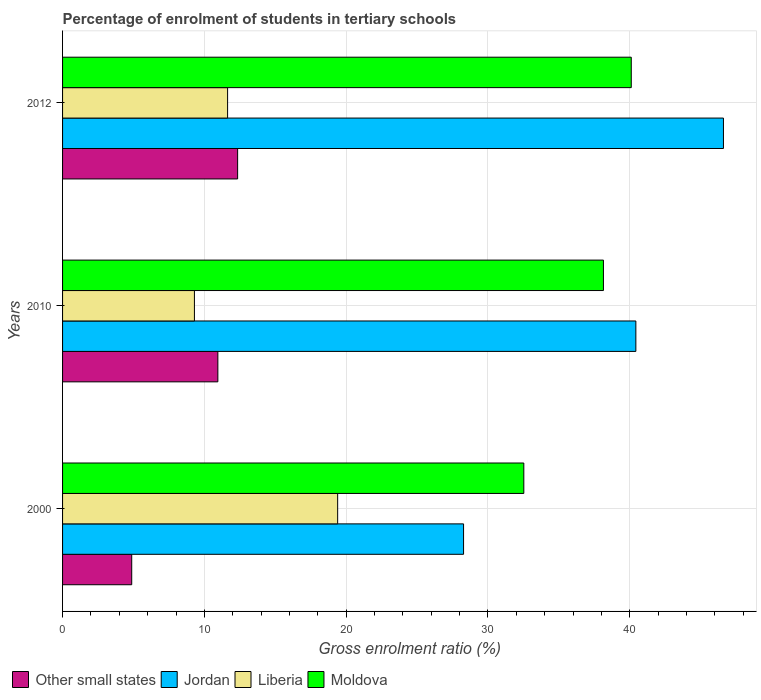How many different coloured bars are there?
Provide a short and direct response. 4. How many groups of bars are there?
Your answer should be very brief. 3. Are the number of bars per tick equal to the number of legend labels?
Provide a succinct answer. Yes. What is the label of the 2nd group of bars from the top?
Your response must be concise. 2010. What is the percentage of students enrolled in tertiary schools in Jordan in 2010?
Offer a terse response. 40.43. Across all years, what is the maximum percentage of students enrolled in tertiary schools in Other small states?
Offer a very short reply. 12.35. Across all years, what is the minimum percentage of students enrolled in tertiary schools in Liberia?
Ensure brevity in your answer.  9.3. In which year was the percentage of students enrolled in tertiary schools in Liberia maximum?
Offer a terse response. 2000. What is the total percentage of students enrolled in tertiary schools in Jordan in the graph?
Keep it short and to the point. 115.32. What is the difference between the percentage of students enrolled in tertiary schools in Jordan in 2010 and that in 2012?
Your answer should be compact. -6.18. What is the difference between the percentage of students enrolled in tertiary schools in Moldova in 2000 and the percentage of students enrolled in tertiary schools in Jordan in 2012?
Ensure brevity in your answer.  -14.08. What is the average percentage of students enrolled in tertiary schools in Other small states per year?
Provide a short and direct response. 9.39. In the year 2000, what is the difference between the percentage of students enrolled in tertiary schools in Moldova and percentage of students enrolled in tertiary schools in Jordan?
Give a very brief answer. 4.25. In how many years, is the percentage of students enrolled in tertiary schools in Liberia greater than 40 %?
Your answer should be very brief. 0. What is the ratio of the percentage of students enrolled in tertiary schools in Moldova in 2000 to that in 2010?
Offer a terse response. 0.85. Is the percentage of students enrolled in tertiary schools in Liberia in 2000 less than that in 2010?
Provide a succinct answer. No. What is the difference between the highest and the second highest percentage of students enrolled in tertiary schools in Liberia?
Offer a terse response. 7.76. What is the difference between the highest and the lowest percentage of students enrolled in tertiary schools in Liberia?
Ensure brevity in your answer.  10.1. In how many years, is the percentage of students enrolled in tertiary schools in Moldova greater than the average percentage of students enrolled in tertiary schools in Moldova taken over all years?
Give a very brief answer. 2. Is the sum of the percentage of students enrolled in tertiary schools in Jordan in 2010 and 2012 greater than the maximum percentage of students enrolled in tertiary schools in Other small states across all years?
Your answer should be very brief. Yes. What does the 3rd bar from the top in 2012 represents?
Give a very brief answer. Jordan. What does the 4th bar from the bottom in 2012 represents?
Ensure brevity in your answer.  Moldova. Are all the bars in the graph horizontal?
Offer a terse response. Yes. How many years are there in the graph?
Give a very brief answer. 3. Where does the legend appear in the graph?
Make the answer very short. Bottom left. How are the legend labels stacked?
Your response must be concise. Horizontal. What is the title of the graph?
Keep it short and to the point. Percentage of enrolment of students in tertiary schools. What is the label or title of the Y-axis?
Provide a succinct answer. Years. What is the Gross enrolment ratio (%) of Other small states in 2000?
Make the answer very short. 4.88. What is the Gross enrolment ratio (%) of Jordan in 2000?
Give a very brief answer. 28.28. What is the Gross enrolment ratio (%) of Liberia in 2000?
Offer a very short reply. 19.4. What is the Gross enrolment ratio (%) in Moldova in 2000?
Offer a terse response. 32.53. What is the Gross enrolment ratio (%) of Other small states in 2010?
Offer a terse response. 10.95. What is the Gross enrolment ratio (%) in Jordan in 2010?
Keep it short and to the point. 40.43. What is the Gross enrolment ratio (%) in Liberia in 2010?
Give a very brief answer. 9.3. What is the Gross enrolment ratio (%) in Moldova in 2010?
Keep it short and to the point. 38.15. What is the Gross enrolment ratio (%) of Other small states in 2012?
Your answer should be very brief. 12.35. What is the Gross enrolment ratio (%) of Jordan in 2012?
Offer a very short reply. 46.61. What is the Gross enrolment ratio (%) in Liberia in 2012?
Provide a short and direct response. 11.64. What is the Gross enrolment ratio (%) in Moldova in 2012?
Provide a short and direct response. 40.11. Across all years, what is the maximum Gross enrolment ratio (%) in Other small states?
Keep it short and to the point. 12.35. Across all years, what is the maximum Gross enrolment ratio (%) in Jordan?
Provide a short and direct response. 46.61. Across all years, what is the maximum Gross enrolment ratio (%) of Liberia?
Provide a succinct answer. 19.4. Across all years, what is the maximum Gross enrolment ratio (%) in Moldova?
Offer a very short reply. 40.11. Across all years, what is the minimum Gross enrolment ratio (%) in Other small states?
Offer a terse response. 4.88. Across all years, what is the minimum Gross enrolment ratio (%) of Jordan?
Ensure brevity in your answer.  28.28. Across all years, what is the minimum Gross enrolment ratio (%) in Liberia?
Ensure brevity in your answer.  9.3. Across all years, what is the minimum Gross enrolment ratio (%) in Moldova?
Ensure brevity in your answer.  32.53. What is the total Gross enrolment ratio (%) of Other small states in the graph?
Provide a succinct answer. 28.18. What is the total Gross enrolment ratio (%) in Jordan in the graph?
Your answer should be very brief. 115.32. What is the total Gross enrolment ratio (%) in Liberia in the graph?
Provide a succinct answer. 40.34. What is the total Gross enrolment ratio (%) in Moldova in the graph?
Provide a short and direct response. 110.78. What is the difference between the Gross enrolment ratio (%) in Other small states in 2000 and that in 2010?
Provide a short and direct response. -6.08. What is the difference between the Gross enrolment ratio (%) of Jordan in 2000 and that in 2010?
Give a very brief answer. -12.15. What is the difference between the Gross enrolment ratio (%) of Liberia in 2000 and that in 2010?
Keep it short and to the point. 10.1. What is the difference between the Gross enrolment ratio (%) of Moldova in 2000 and that in 2010?
Make the answer very short. -5.62. What is the difference between the Gross enrolment ratio (%) in Other small states in 2000 and that in 2012?
Your answer should be very brief. -7.47. What is the difference between the Gross enrolment ratio (%) of Jordan in 2000 and that in 2012?
Give a very brief answer. -18.33. What is the difference between the Gross enrolment ratio (%) of Liberia in 2000 and that in 2012?
Offer a very short reply. 7.76. What is the difference between the Gross enrolment ratio (%) of Moldova in 2000 and that in 2012?
Ensure brevity in your answer.  -7.58. What is the difference between the Gross enrolment ratio (%) of Other small states in 2010 and that in 2012?
Offer a very short reply. -1.39. What is the difference between the Gross enrolment ratio (%) in Jordan in 2010 and that in 2012?
Offer a very short reply. -6.18. What is the difference between the Gross enrolment ratio (%) in Liberia in 2010 and that in 2012?
Give a very brief answer. -2.34. What is the difference between the Gross enrolment ratio (%) in Moldova in 2010 and that in 2012?
Provide a short and direct response. -1.96. What is the difference between the Gross enrolment ratio (%) of Other small states in 2000 and the Gross enrolment ratio (%) of Jordan in 2010?
Offer a terse response. -35.56. What is the difference between the Gross enrolment ratio (%) of Other small states in 2000 and the Gross enrolment ratio (%) of Liberia in 2010?
Keep it short and to the point. -4.42. What is the difference between the Gross enrolment ratio (%) of Other small states in 2000 and the Gross enrolment ratio (%) of Moldova in 2010?
Offer a very short reply. -33.27. What is the difference between the Gross enrolment ratio (%) of Jordan in 2000 and the Gross enrolment ratio (%) of Liberia in 2010?
Offer a very short reply. 18.98. What is the difference between the Gross enrolment ratio (%) in Jordan in 2000 and the Gross enrolment ratio (%) in Moldova in 2010?
Your response must be concise. -9.86. What is the difference between the Gross enrolment ratio (%) in Liberia in 2000 and the Gross enrolment ratio (%) in Moldova in 2010?
Keep it short and to the point. -18.74. What is the difference between the Gross enrolment ratio (%) in Other small states in 2000 and the Gross enrolment ratio (%) in Jordan in 2012?
Provide a succinct answer. -41.73. What is the difference between the Gross enrolment ratio (%) of Other small states in 2000 and the Gross enrolment ratio (%) of Liberia in 2012?
Make the answer very short. -6.76. What is the difference between the Gross enrolment ratio (%) in Other small states in 2000 and the Gross enrolment ratio (%) in Moldova in 2012?
Provide a short and direct response. -35.23. What is the difference between the Gross enrolment ratio (%) of Jordan in 2000 and the Gross enrolment ratio (%) of Liberia in 2012?
Keep it short and to the point. 16.64. What is the difference between the Gross enrolment ratio (%) in Jordan in 2000 and the Gross enrolment ratio (%) in Moldova in 2012?
Provide a short and direct response. -11.83. What is the difference between the Gross enrolment ratio (%) of Liberia in 2000 and the Gross enrolment ratio (%) of Moldova in 2012?
Provide a short and direct response. -20.71. What is the difference between the Gross enrolment ratio (%) in Other small states in 2010 and the Gross enrolment ratio (%) in Jordan in 2012?
Your answer should be compact. -35.66. What is the difference between the Gross enrolment ratio (%) in Other small states in 2010 and the Gross enrolment ratio (%) in Liberia in 2012?
Ensure brevity in your answer.  -0.69. What is the difference between the Gross enrolment ratio (%) in Other small states in 2010 and the Gross enrolment ratio (%) in Moldova in 2012?
Your answer should be compact. -29.16. What is the difference between the Gross enrolment ratio (%) in Jordan in 2010 and the Gross enrolment ratio (%) in Liberia in 2012?
Make the answer very short. 28.79. What is the difference between the Gross enrolment ratio (%) in Jordan in 2010 and the Gross enrolment ratio (%) in Moldova in 2012?
Provide a succinct answer. 0.32. What is the difference between the Gross enrolment ratio (%) of Liberia in 2010 and the Gross enrolment ratio (%) of Moldova in 2012?
Make the answer very short. -30.81. What is the average Gross enrolment ratio (%) of Other small states per year?
Give a very brief answer. 9.39. What is the average Gross enrolment ratio (%) in Jordan per year?
Offer a very short reply. 38.44. What is the average Gross enrolment ratio (%) of Liberia per year?
Provide a succinct answer. 13.45. What is the average Gross enrolment ratio (%) in Moldova per year?
Make the answer very short. 36.93. In the year 2000, what is the difference between the Gross enrolment ratio (%) in Other small states and Gross enrolment ratio (%) in Jordan?
Make the answer very short. -23.4. In the year 2000, what is the difference between the Gross enrolment ratio (%) in Other small states and Gross enrolment ratio (%) in Liberia?
Keep it short and to the point. -14.52. In the year 2000, what is the difference between the Gross enrolment ratio (%) in Other small states and Gross enrolment ratio (%) in Moldova?
Provide a succinct answer. -27.65. In the year 2000, what is the difference between the Gross enrolment ratio (%) of Jordan and Gross enrolment ratio (%) of Liberia?
Keep it short and to the point. 8.88. In the year 2000, what is the difference between the Gross enrolment ratio (%) in Jordan and Gross enrolment ratio (%) in Moldova?
Your answer should be very brief. -4.25. In the year 2000, what is the difference between the Gross enrolment ratio (%) in Liberia and Gross enrolment ratio (%) in Moldova?
Your answer should be compact. -13.13. In the year 2010, what is the difference between the Gross enrolment ratio (%) in Other small states and Gross enrolment ratio (%) in Jordan?
Make the answer very short. -29.48. In the year 2010, what is the difference between the Gross enrolment ratio (%) in Other small states and Gross enrolment ratio (%) in Liberia?
Your response must be concise. 1.65. In the year 2010, what is the difference between the Gross enrolment ratio (%) in Other small states and Gross enrolment ratio (%) in Moldova?
Offer a very short reply. -27.19. In the year 2010, what is the difference between the Gross enrolment ratio (%) in Jordan and Gross enrolment ratio (%) in Liberia?
Keep it short and to the point. 31.13. In the year 2010, what is the difference between the Gross enrolment ratio (%) of Jordan and Gross enrolment ratio (%) of Moldova?
Give a very brief answer. 2.29. In the year 2010, what is the difference between the Gross enrolment ratio (%) of Liberia and Gross enrolment ratio (%) of Moldova?
Ensure brevity in your answer.  -28.85. In the year 2012, what is the difference between the Gross enrolment ratio (%) in Other small states and Gross enrolment ratio (%) in Jordan?
Keep it short and to the point. -34.26. In the year 2012, what is the difference between the Gross enrolment ratio (%) of Other small states and Gross enrolment ratio (%) of Liberia?
Provide a succinct answer. 0.71. In the year 2012, what is the difference between the Gross enrolment ratio (%) of Other small states and Gross enrolment ratio (%) of Moldova?
Make the answer very short. -27.76. In the year 2012, what is the difference between the Gross enrolment ratio (%) in Jordan and Gross enrolment ratio (%) in Liberia?
Provide a short and direct response. 34.97. In the year 2012, what is the difference between the Gross enrolment ratio (%) of Jordan and Gross enrolment ratio (%) of Moldova?
Give a very brief answer. 6.5. In the year 2012, what is the difference between the Gross enrolment ratio (%) of Liberia and Gross enrolment ratio (%) of Moldova?
Provide a short and direct response. -28.47. What is the ratio of the Gross enrolment ratio (%) in Other small states in 2000 to that in 2010?
Offer a very short reply. 0.45. What is the ratio of the Gross enrolment ratio (%) of Jordan in 2000 to that in 2010?
Your answer should be very brief. 0.7. What is the ratio of the Gross enrolment ratio (%) of Liberia in 2000 to that in 2010?
Offer a very short reply. 2.09. What is the ratio of the Gross enrolment ratio (%) in Moldova in 2000 to that in 2010?
Your answer should be very brief. 0.85. What is the ratio of the Gross enrolment ratio (%) in Other small states in 2000 to that in 2012?
Offer a very short reply. 0.4. What is the ratio of the Gross enrolment ratio (%) of Jordan in 2000 to that in 2012?
Offer a very short reply. 0.61. What is the ratio of the Gross enrolment ratio (%) in Liberia in 2000 to that in 2012?
Provide a succinct answer. 1.67. What is the ratio of the Gross enrolment ratio (%) in Moldova in 2000 to that in 2012?
Provide a short and direct response. 0.81. What is the ratio of the Gross enrolment ratio (%) in Other small states in 2010 to that in 2012?
Your answer should be very brief. 0.89. What is the ratio of the Gross enrolment ratio (%) of Jordan in 2010 to that in 2012?
Offer a very short reply. 0.87. What is the ratio of the Gross enrolment ratio (%) of Liberia in 2010 to that in 2012?
Provide a succinct answer. 0.8. What is the ratio of the Gross enrolment ratio (%) in Moldova in 2010 to that in 2012?
Your answer should be very brief. 0.95. What is the difference between the highest and the second highest Gross enrolment ratio (%) of Other small states?
Your answer should be very brief. 1.39. What is the difference between the highest and the second highest Gross enrolment ratio (%) of Jordan?
Your response must be concise. 6.18. What is the difference between the highest and the second highest Gross enrolment ratio (%) of Liberia?
Your response must be concise. 7.76. What is the difference between the highest and the second highest Gross enrolment ratio (%) in Moldova?
Provide a succinct answer. 1.96. What is the difference between the highest and the lowest Gross enrolment ratio (%) of Other small states?
Offer a terse response. 7.47. What is the difference between the highest and the lowest Gross enrolment ratio (%) in Jordan?
Your answer should be very brief. 18.33. What is the difference between the highest and the lowest Gross enrolment ratio (%) of Liberia?
Your answer should be compact. 10.1. What is the difference between the highest and the lowest Gross enrolment ratio (%) of Moldova?
Your response must be concise. 7.58. 